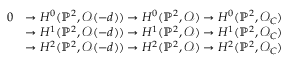<formula> <loc_0><loc_0><loc_500><loc_500>{ \begin{array} { r l } { 0 } & { \to H ^ { 0 } ( \mathbb { P } ^ { 2 } , { \mathcal { O } } ( - d ) ) \to H ^ { 0 } ( \mathbb { P } ^ { 2 } , { \mathcal { O } } ) \to H ^ { 0 } ( \mathbb { P } ^ { 2 } , { \mathcal { O } } _ { C } ) } \\ & { \to H ^ { 1 } ( \mathbb { P } ^ { 2 } , { \mathcal { O } } ( - d ) ) \to H ^ { 1 } ( \mathbb { P } ^ { 2 } , { \mathcal { O } } ) \to H ^ { 1 } ( \mathbb { P } ^ { 2 } , { \mathcal { O } } _ { C } ) } \\ & { \to H ^ { 2 } ( \mathbb { P } ^ { 2 } , { \mathcal { O } } ( - d ) ) \to H ^ { 2 } ( \mathbb { P } ^ { 2 } , { \mathcal { O } } ) \to H ^ { 2 } ( \mathbb { P } ^ { 2 } , { \mathcal { O } } _ { C } ) } \end{array} }</formula> 